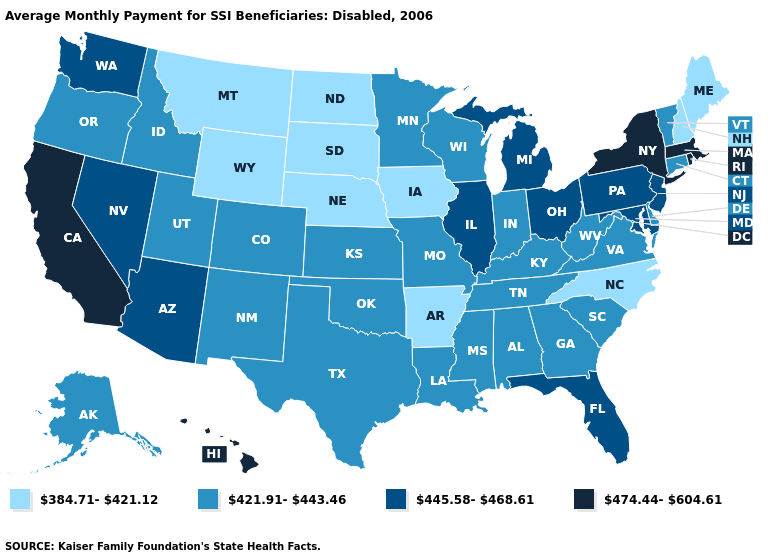Name the states that have a value in the range 384.71-421.12?
Quick response, please. Arkansas, Iowa, Maine, Montana, Nebraska, New Hampshire, North Carolina, North Dakota, South Dakota, Wyoming. How many symbols are there in the legend?
Concise answer only. 4. Does the map have missing data?
Quick response, please. No. Name the states that have a value in the range 421.91-443.46?
Give a very brief answer. Alabama, Alaska, Colorado, Connecticut, Delaware, Georgia, Idaho, Indiana, Kansas, Kentucky, Louisiana, Minnesota, Mississippi, Missouri, New Mexico, Oklahoma, Oregon, South Carolina, Tennessee, Texas, Utah, Vermont, Virginia, West Virginia, Wisconsin. Which states have the lowest value in the Northeast?
Quick response, please. Maine, New Hampshire. Does the map have missing data?
Short answer required. No. What is the highest value in the USA?
Short answer required. 474.44-604.61. Among the states that border Utah , does Wyoming have the lowest value?
Short answer required. Yes. Which states have the lowest value in the West?
Give a very brief answer. Montana, Wyoming. Name the states that have a value in the range 445.58-468.61?
Answer briefly. Arizona, Florida, Illinois, Maryland, Michigan, Nevada, New Jersey, Ohio, Pennsylvania, Washington. What is the value of Illinois?
Concise answer only. 445.58-468.61. Among the states that border New York , which have the lowest value?
Keep it brief. Connecticut, Vermont. Among the states that border Utah , does New Mexico have the highest value?
Give a very brief answer. No. Among the states that border Rhode Island , which have the highest value?
Answer briefly. Massachusetts. What is the value of Illinois?
Quick response, please. 445.58-468.61. 